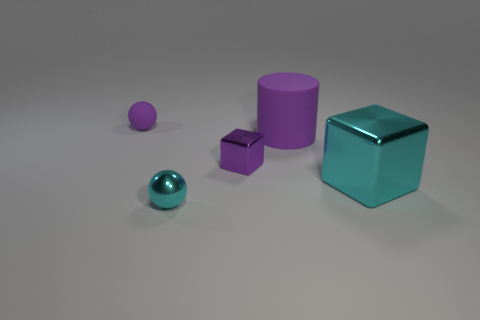Add 1 tiny red cylinders. How many objects exist? 6 Subtract all balls. How many objects are left? 3 Add 4 cyan blocks. How many cyan blocks are left? 5 Add 2 tiny green matte balls. How many tiny green matte balls exist? 2 Subtract 0 yellow cubes. How many objects are left? 5 Subtract all gray cubes. Subtract all yellow cylinders. How many cubes are left? 2 Subtract all big red blocks. Subtract all cyan metallic things. How many objects are left? 3 